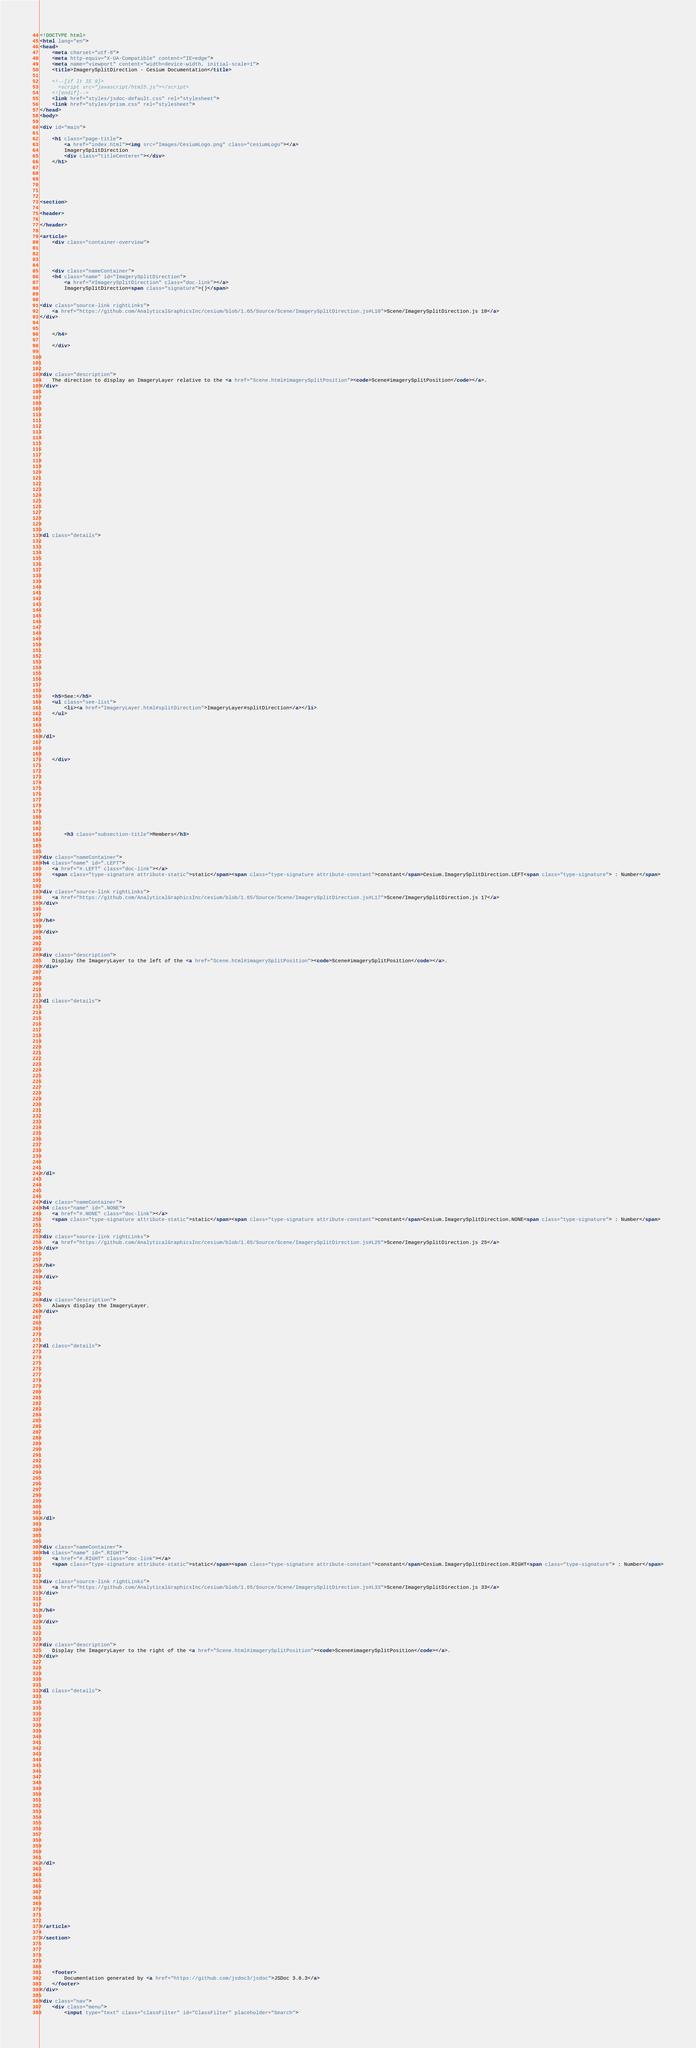<code> <loc_0><loc_0><loc_500><loc_500><_HTML_><!DOCTYPE html>
<html lang="en">
<head>
    <meta charset="utf-8">
    <meta http-equiv="X-UA-Compatible" content="IE=edge">
    <meta name="viewport" content="width=device-width, initial-scale=1">
    <title>ImagerySplitDirection - Cesium Documentation</title>

    <!--[if lt IE 9]>
      <script src="javascript/html5.js"></script>
    <![endif]-->
    <link href="styles/jsdoc-default.css" rel="stylesheet">
    <link href="styles/prism.css" rel="stylesheet">
</head>
<body>

<div id="main">

    <h1 class="page-title">
        <a href="index.html"><img src="Images/CesiumLogo.png" class="cesiumLogo"></a>
        ImagerySplitDirection
        <div class="titleCenterer"></div>
    </h1>

    




<section>

<header>
    
</header>

<article>
    <div class="container-overview">
    

    
        
    <div class="nameContainer">
    <h4 class="name" id="ImagerySplitDirection">
        <a href="#ImagerySplitDirection" class="doc-link"></a>
        ImagerySplitDirection<span class="signature">()</span>
        

<div class="source-link rightLinks">
    <a href="https://github.com/AnalyticalGraphicsInc/cesium/blob/1.65/Source/Scene/ImagerySplitDirection.js#L10">Scene/ImagerySplitDirection.js 10</a>
</div>


    </h4>

    </div>

    


<div class="description">
    The direction to display an ImageryLayer relative to the <a href="Scene.html#imagerySplitPosition"><code>Scene#imagerySplitPosition</code></a>.
</div>

























<dl class="details">


    

    

    

    

    

    

    

    

    

    

    

    

    
    <h5>See:</h5>
    <ul class="see-list">
        <li><a href="ImageryLayer.html#splitDirection">ImageryLayer#splitDirection</a></li>
    </ul>
    

    
</dl>


    
    </div>

    

    

    

    

    

    
        <h3 class="subsection-title">Members</h3>

        
            
<div class="nameContainer">
<h4 class="name" id=".LEFT">
    <a href="#.LEFT" class="doc-link"></a>
    <span class="type-signature attribute-static">static</span><span class="type-signature attribute-constant">constant</span>Cesium.ImagerySplitDirection.LEFT<span class="type-signature"> : Number</span>
    

<div class="source-link rightLinks">
    <a href="https://github.com/AnalyticalGraphicsInc/cesium/blob/1.65/Source/Scene/ImagerySplitDirection.js#L17">Scene/ImagerySplitDirection.js 17</a>
</div>


</h4>

</div>



<div class="description">
    Display the ImageryLayer to the left of the <a href="Scene.html#imagerySplitPosition"><code>Scene#imagerySplitPosition</code></a>.
</div>





<dl class="details">


    

    

    

    

    

    

    

    

    

    

    

    

    

    
</dl>


        
            
<div class="nameContainer">
<h4 class="name" id=".NONE">
    <a href="#.NONE" class="doc-link"></a>
    <span class="type-signature attribute-static">static</span><span class="type-signature attribute-constant">constant</span>Cesium.ImagerySplitDirection.NONE<span class="type-signature"> : Number</span>
    

<div class="source-link rightLinks">
    <a href="https://github.com/AnalyticalGraphicsInc/cesium/blob/1.65/Source/Scene/ImagerySplitDirection.js#L25">Scene/ImagerySplitDirection.js 25</a>
</div>


</h4>

</div>



<div class="description">
    Always display the ImageryLayer.
</div>





<dl class="details">


    

    

    

    

    

    

    

    

    

    

    

    

    

    
</dl>


        
            
<div class="nameContainer">
<h4 class="name" id=".RIGHT">
    <a href="#.RIGHT" class="doc-link"></a>
    <span class="type-signature attribute-static">static</span><span class="type-signature attribute-constant">constant</span>Cesium.ImagerySplitDirection.RIGHT<span class="type-signature"> : Number</span>
    

<div class="source-link rightLinks">
    <a href="https://github.com/AnalyticalGraphicsInc/cesium/blob/1.65/Source/Scene/ImagerySplitDirection.js#L33">Scene/ImagerySplitDirection.js 33</a>
</div>


</h4>

</div>



<div class="description">
    Display the ImageryLayer to the right of the <a href="Scene.html#imagerySplitPosition"><code>Scene#imagerySplitPosition</code></a>.
</div>





<dl class="details">


    

    

    

    

    

    

    

    

    

    

    

    

    

    
</dl>


        
    

    

    

    
</article>

</section>





    <footer>
        Documentation generated by <a href="https://github.com/jsdoc3/jsdoc">JSDoc 3.6.3</a>
    </footer>
</div>

<div class="nav">
    <div class="menu">
        <input type="text" class="classFilter" id="ClassFilter" placeholder="Search"></code> 